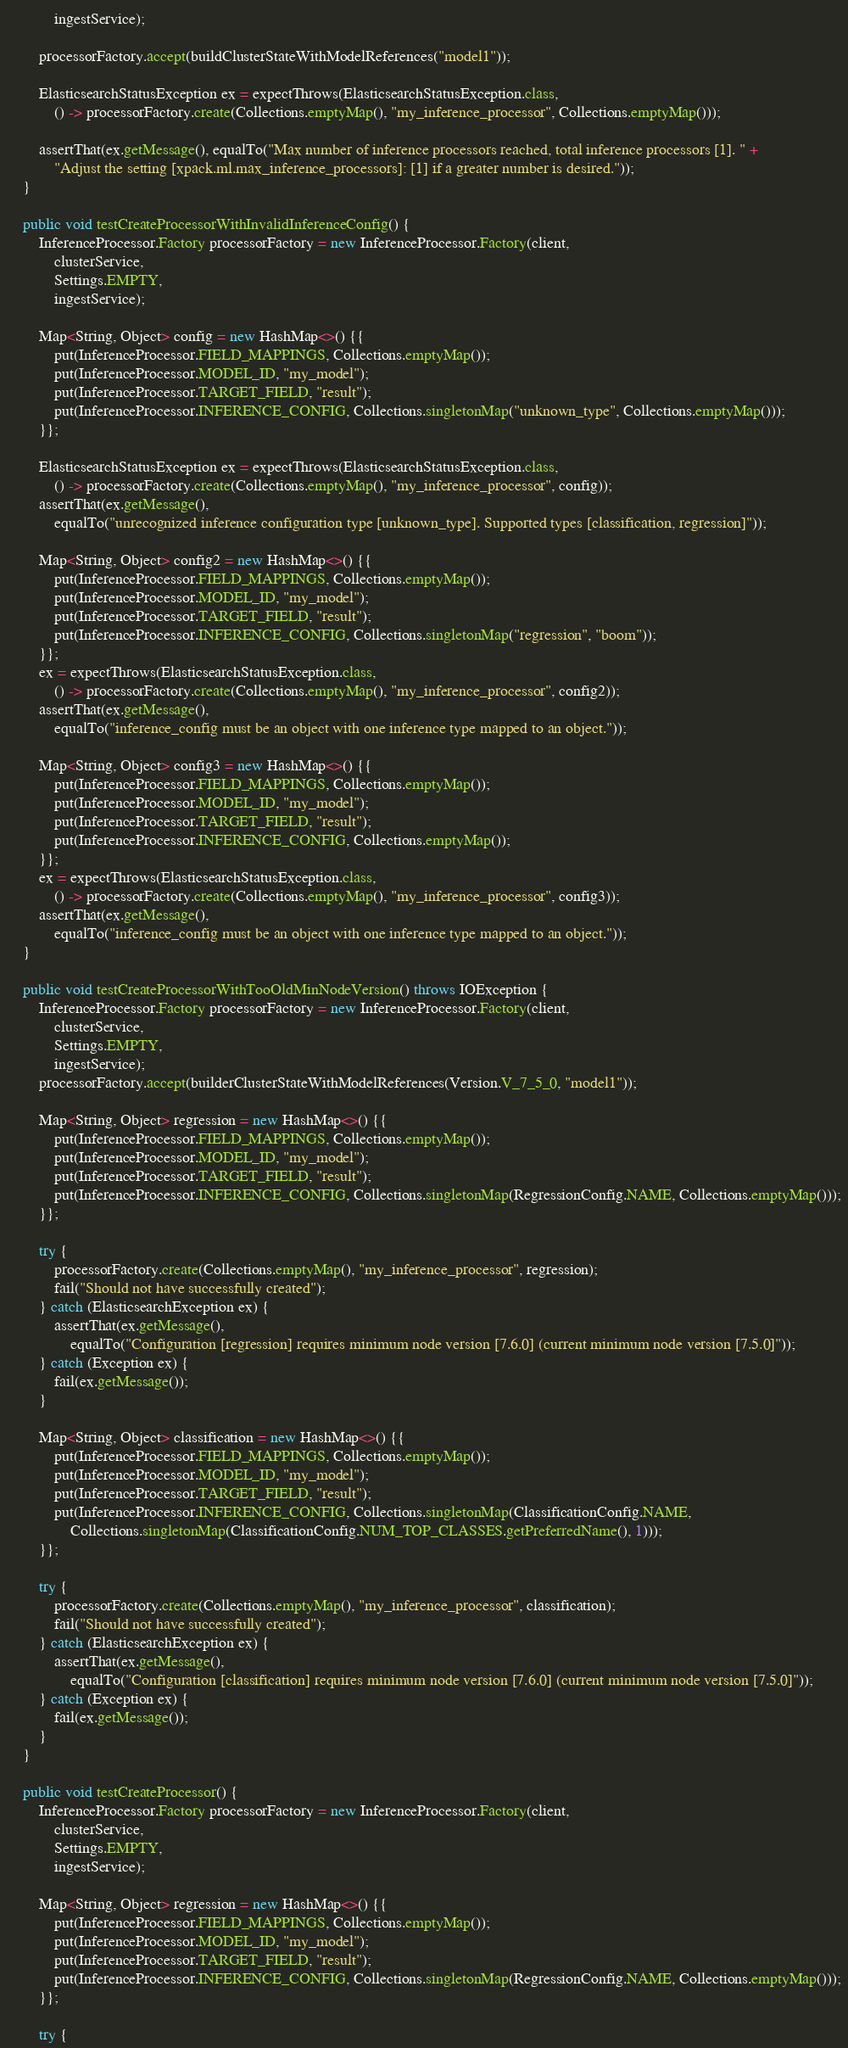Convert code to text. <code><loc_0><loc_0><loc_500><loc_500><_Java_>            ingestService);

        processorFactory.accept(buildClusterStateWithModelReferences("model1"));

        ElasticsearchStatusException ex = expectThrows(ElasticsearchStatusException.class,
            () -> processorFactory.create(Collections.emptyMap(), "my_inference_processor", Collections.emptyMap()));

        assertThat(ex.getMessage(), equalTo("Max number of inference processors reached, total inference processors [1]. " +
            "Adjust the setting [xpack.ml.max_inference_processors]: [1] if a greater number is desired."));
    }

    public void testCreateProcessorWithInvalidInferenceConfig() {
        InferenceProcessor.Factory processorFactory = new InferenceProcessor.Factory(client,
            clusterService,
            Settings.EMPTY,
            ingestService);

        Map<String, Object> config = new HashMap<>() {{
            put(InferenceProcessor.FIELD_MAPPINGS, Collections.emptyMap());
            put(InferenceProcessor.MODEL_ID, "my_model");
            put(InferenceProcessor.TARGET_FIELD, "result");
            put(InferenceProcessor.INFERENCE_CONFIG, Collections.singletonMap("unknown_type", Collections.emptyMap()));
        }};

        ElasticsearchStatusException ex = expectThrows(ElasticsearchStatusException.class,
            () -> processorFactory.create(Collections.emptyMap(), "my_inference_processor", config));
        assertThat(ex.getMessage(),
            equalTo("unrecognized inference configuration type [unknown_type]. Supported types [classification, regression]"));

        Map<String, Object> config2 = new HashMap<>() {{
            put(InferenceProcessor.FIELD_MAPPINGS, Collections.emptyMap());
            put(InferenceProcessor.MODEL_ID, "my_model");
            put(InferenceProcessor.TARGET_FIELD, "result");
            put(InferenceProcessor.INFERENCE_CONFIG, Collections.singletonMap("regression", "boom"));
        }};
        ex = expectThrows(ElasticsearchStatusException.class,
            () -> processorFactory.create(Collections.emptyMap(), "my_inference_processor", config2));
        assertThat(ex.getMessage(),
            equalTo("inference_config must be an object with one inference type mapped to an object."));

        Map<String, Object> config3 = new HashMap<>() {{
            put(InferenceProcessor.FIELD_MAPPINGS, Collections.emptyMap());
            put(InferenceProcessor.MODEL_ID, "my_model");
            put(InferenceProcessor.TARGET_FIELD, "result");
            put(InferenceProcessor.INFERENCE_CONFIG, Collections.emptyMap());
        }};
        ex = expectThrows(ElasticsearchStatusException.class,
            () -> processorFactory.create(Collections.emptyMap(), "my_inference_processor", config3));
        assertThat(ex.getMessage(),
            equalTo("inference_config must be an object with one inference type mapped to an object."));
    }

    public void testCreateProcessorWithTooOldMinNodeVersion() throws IOException {
        InferenceProcessor.Factory processorFactory = new InferenceProcessor.Factory(client,
            clusterService,
            Settings.EMPTY,
            ingestService);
        processorFactory.accept(builderClusterStateWithModelReferences(Version.V_7_5_0, "model1"));

        Map<String, Object> regression = new HashMap<>() {{
            put(InferenceProcessor.FIELD_MAPPINGS, Collections.emptyMap());
            put(InferenceProcessor.MODEL_ID, "my_model");
            put(InferenceProcessor.TARGET_FIELD, "result");
            put(InferenceProcessor.INFERENCE_CONFIG, Collections.singletonMap(RegressionConfig.NAME, Collections.emptyMap()));
        }};

        try {
            processorFactory.create(Collections.emptyMap(), "my_inference_processor", regression);
            fail("Should not have successfully created");
        } catch (ElasticsearchException ex) {
            assertThat(ex.getMessage(),
                equalTo("Configuration [regression] requires minimum node version [7.6.0] (current minimum node version [7.5.0]"));
        } catch (Exception ex) {
            fail(ex.getMessage());
        }

        Map<String, Object> classification = new HashMap<>() {{
            put(InferenceProcessor.FIELD_MAPPINGS, Collections.emptyMap());
            put(InferenceProcessor.MODEL_ID, "my_model");
            put(InferenceProcessor.TARGET_FIELD, "result");
            put(InferenceProcessor.INFERENCE_CONFIG, Collections.singletonMap(ClassificationConfig.NAME,
                Collections.singletonMap(ClassificationConfig.NUM_TOP_CLASSES.getPreferredName(), 1)));
        }};

        try {
            processorFactory.create(Collections.emptyMap(), "my_inference_processor", classification);
            fail("Should not have successfully created");
        } catch (ElasticsearchException ex) {
            assertThat(ex.getMessage(),
                equalTo("Configuration [classification] requires minimum node version [7.6.0] (current minimum node version [7.5.0]"));
        } catch (Exception ex) {
            fail(ex.getMessage());
        }
    }

    public void testCreateProcessor() {
        InferenceProcessor.Factory processorFactory = new InferenceProcessor.Factory(client,
            clusterService,
            Settings.EMPTY,
            ingestService);

        Map<String, Object> regression = new HashMap<>() {{
            put(InferenceProcessor.FIELD_MAPPINGS, Collections.emptyMap());
            put(InferenceProcessor.MODEL_ID, "my_model");
            put(InferenceProcessor.TARGET_FIELD, "result");
            put(InferenceProcessor.INFERENCE_CONFIG, Collections.singletonMap(RegressionConfig.NAME, Collections.emptyMap()));
        }};

        try {</code> 